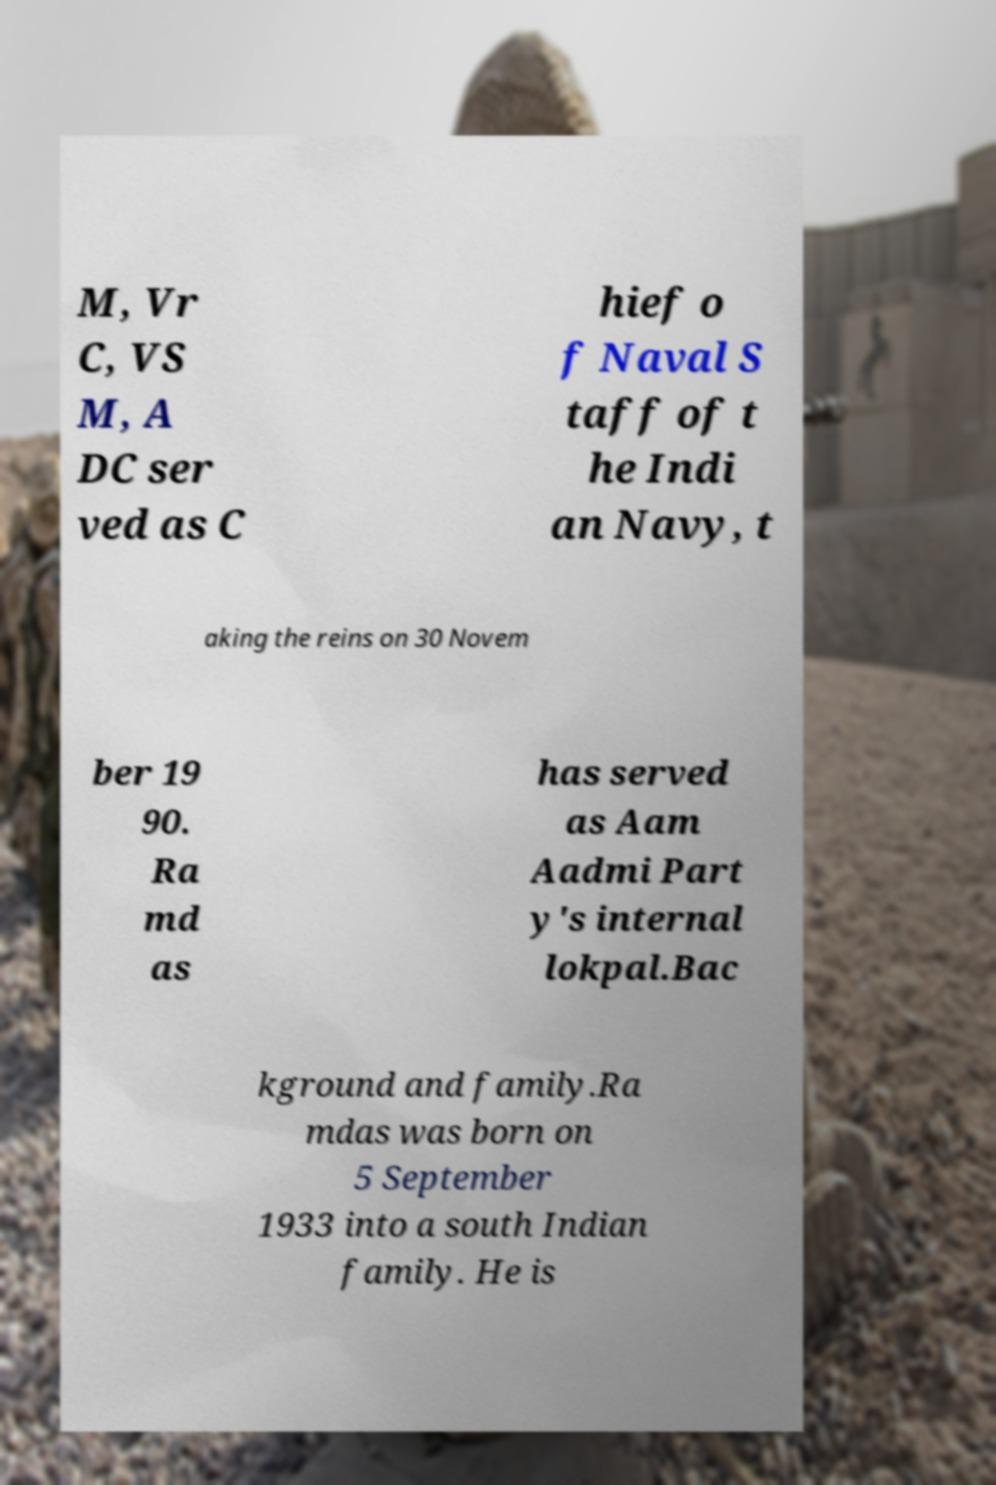What messages or text are displayed in this image? I need them in a readable, typed format. M, Vr C, VS M, A DC ser ved as C hief o f Naval S taff of t he Indi an Navy, t aking the reins on 30 Novem ber 19 90. Ra md as has served as Aam Aadmi Part y's internal lokpal.Bac kground and family.Ra mdas was born on 5 September 1933 into a south Indian family. He is 